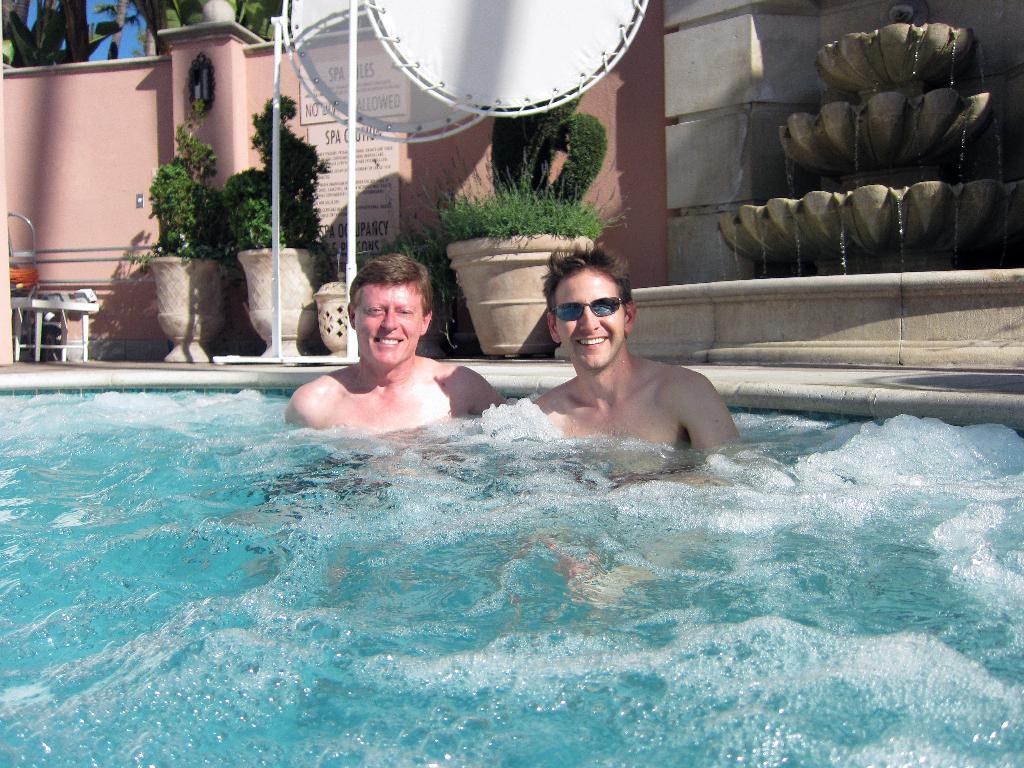In one or two sentences, can you explain what this image depicts? In this picture there are two men smiling and we can see water, boards, poles, plants with pots and wall. In the background of the image we can see the sky and leaves. 